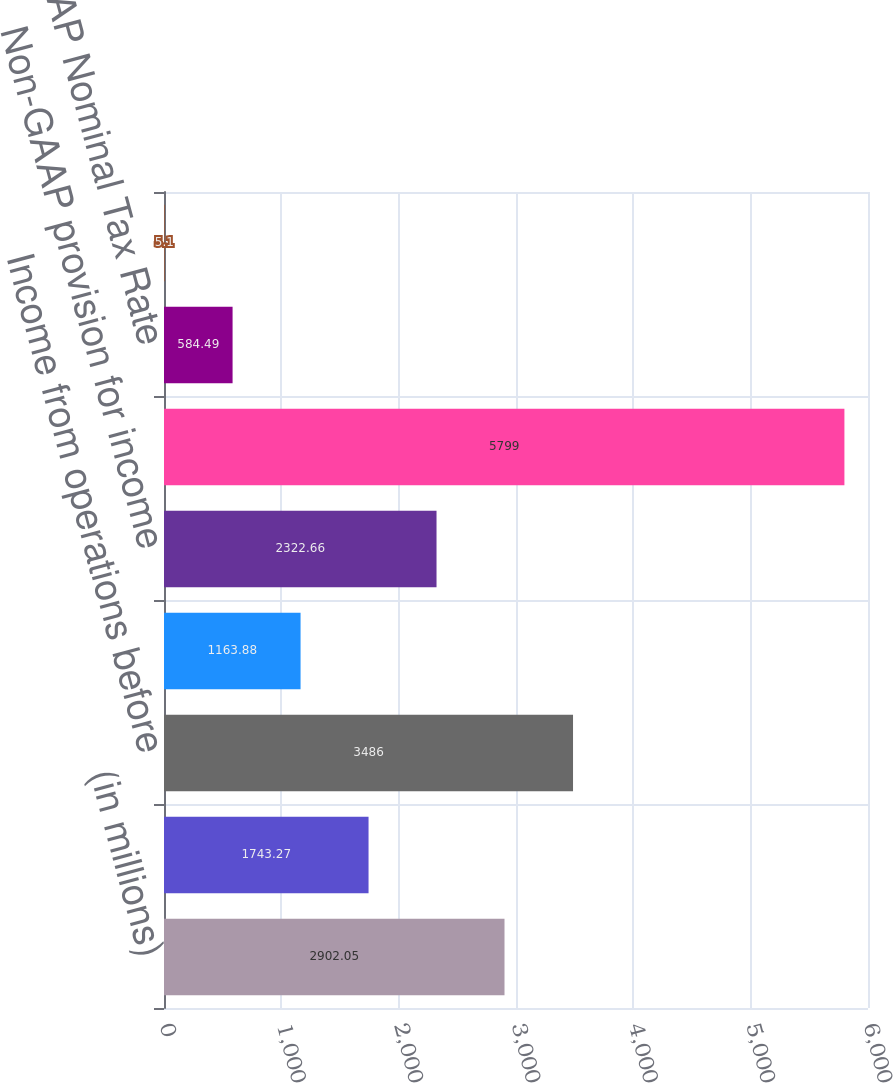Convert chart to OTSL. <chart><loc_0><loc_0><loc_500><loc_500><bar_chart><fcel>(in millions)<fcel>Provision for income taxes<fcel>Income from operations before<fcel>Effective tax rate<fcel>Non-GAAP provision for income<fcel>Non-GAAP income from<fcel>Non-GAAP Nominal Tax Rate<fcel>Difference between the<nl><fcel>2902.05<fcel>1743.27<fcel>3486<fcel>1163.88<fcel>2322.66<fcel>5799<fcel>584.49<fcel>5.1<nl></chart> 